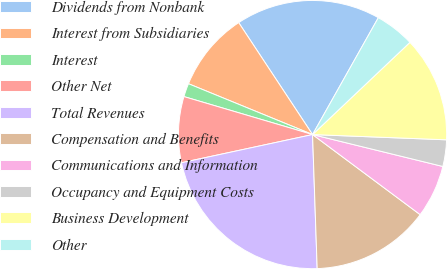<chart> <loc_0><loc_0><loc_500><loc_500><pie_chart><fcel>Dividends from Nonbank<fcel>Interest from Subsidiaries<fcel>Interest<fcel>Other Net<fcel>Total Revenues<fcel>Compensation and Benefits<fcel>Communications and Information<fcel>Occupancy and Equipment Costs<fcel>Business Development<fcel>Other<nl><fcel>17.44%<fcel>9.53%<fcel>1.62%<fcel>7.94%<fcel>22.18%<fcel>14.27%<fcel>6.36%<fcel>3.2%<fcel>12.69%<fcel>4.78%<nl></chart> 